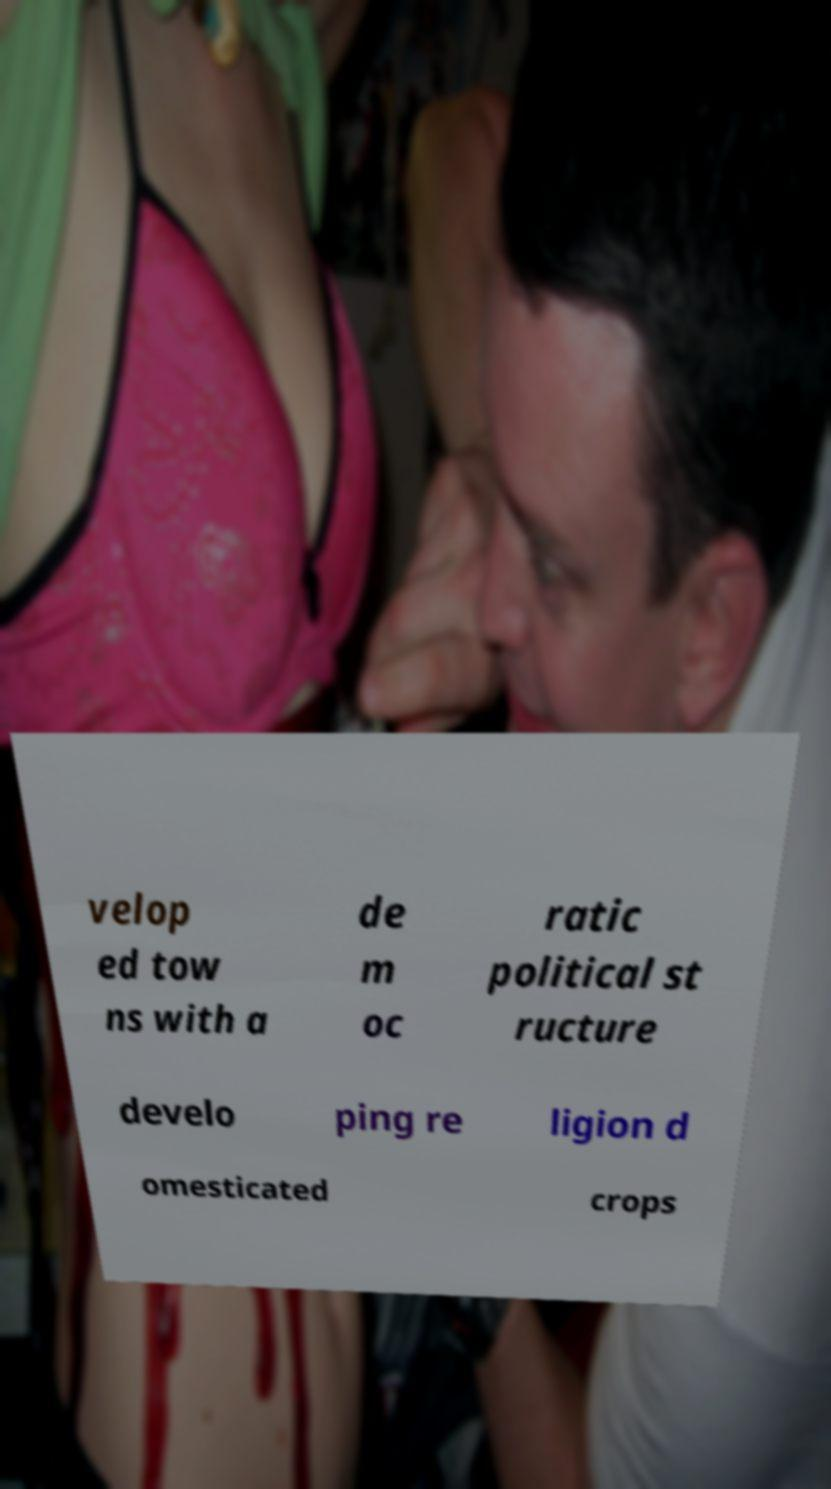Can you accurately transcribe the text from the provided image for me? velop ed tow ns with a de m oc ratic political st ructure develo ping re ligion d omesticated crops 